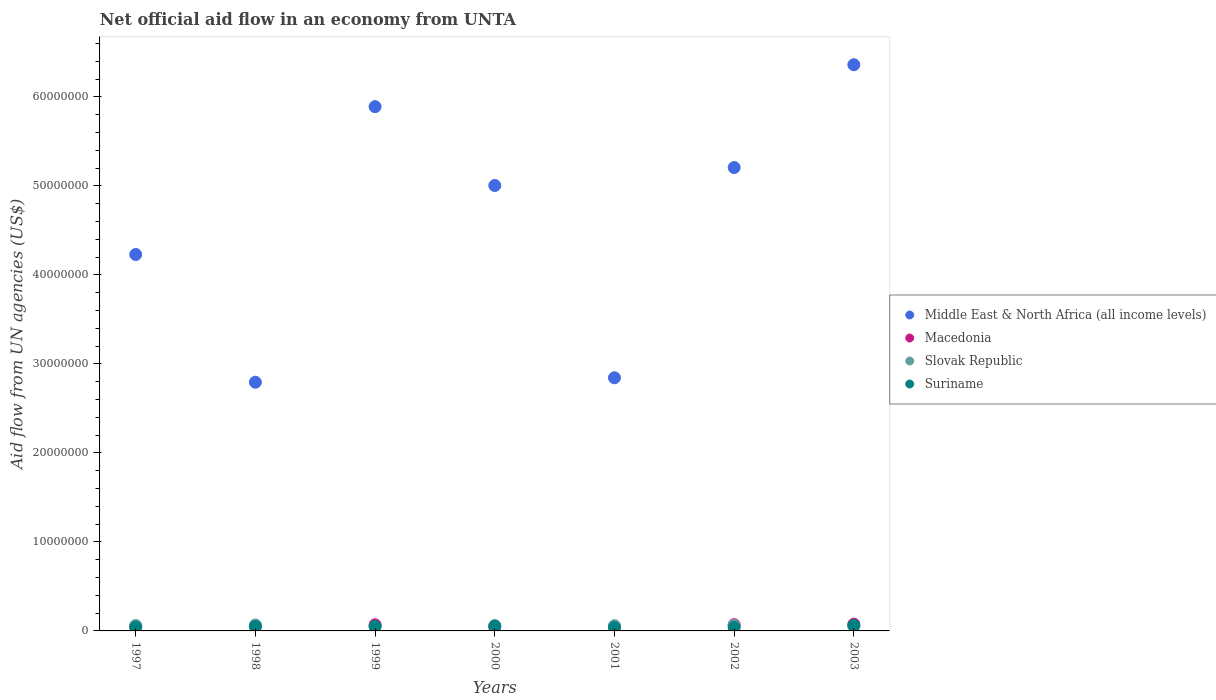How many different coloured dotlines are there?
Your response must be concise. 4. Is the number of dotlines equal to the number of legend labels?
Your answer should be very brief. Yes. What is the net official aid flow in Middle East & North Africa (all income levels) in 2003?
Make the answer very short. 6.36e+07. Across all years, what is the maximum net official aid flow in Slovak Republic?
Make the answer very short. 6.70e+05. Across all years, what is the minimum net official aid flow in Middle East & North Africa (all income levels)?
Provide a short and direct response. 2.79e+07. In which year was the net official aid flow in Macedonia maximum?
Your answer should be compact. 2003. In which year was the net official aid flow in Slovak Republic minimum?
Your response must be concise. 1999. What is the total net official aid flow in Suriname in the graph?
Provide a succinct answer. 3.36e+06. What is the difference between the net official aid flow in Macedonia in 1998 and the net official aid flow in Middle East & North Africa (all income levels) in 2003?
Give a very brief answer. -6.31e+07. What is the average net official aid flow in Macedonia per year?
Your answer should be very brief. 5.83e+05. In the year 2000, what is the difference between the net official aid flow in Suriname and net official aid flow in Macedonia?
Provide a succinct answer. 1.10e+05. In how many years, is the net official aid flow in Slovak Republic greater than 16000000 US$?
Give a very brief answer. 0. What is the ratio of the net official aid flow in Suriname in 2000 to that in 2003?
Your response must be concise. 0.87. Is the difference between the net official aid flow in Suriname in 1998 and 1999 greater than the difference between the net official aid flow in Macedonia in 1998 and 1999?
Your response must be concise. Yes. What is the difference between the highest and the second highest net official aid flow in Suriname?
Your answer should be very brief. 8.00e+04. What is the difference between the highest and the lowest net official aid flow in Middle East & North Africa (all income levels)?
Your response must be concise. 3.57e+07. In how many years, is the net official aid flow in Middle East & North Africa (all income levels) greater than the average net official aid flow in Middle East & North Africa (all income levels) taken over all years?
Keep it short and to the point. 4. Is the sum of the net official aid flow in Macedonia in 1997 and 2000 greater than the maximum net official aid flow in Suriname across all years?
Your answer should be compact. Yes. Is it the case that in every year, the sum of the net official aid flow in Middle East & North Africa (all income levels) and net official aid flow in Suriname  is greater than the sum of net official aid flow in Slovak Republic and net official aid flow in Macedonia?
Ensure brevity in your answer.  Yes. Is the net official aid flow in Macedonia strictly less than the net official aid flow in Slovak Republic over the years?
Keep it short and to the point. No. How many years are there in the graph?
Ensure brevity in your answer.  7. What is the difference between two consecutive major ticks on the Y-axis?
Provide a succinct answer. 1.00e+07. Are the values on the major ticks of Y-axis written in scientific E-notation?
Provide a succinct answer. No. Does the graph contain any zero values?
Your answer should be very brief. No. Where does the legend appear in the graph?
Provide a succinct answer. Center right. How many legend labels are there?
Offer a terse response. 4. How are the legend labels stacked?
Keep it short and to the point. Vertical. What is the title of the graph?
Keep it short and to the point. Net official aid flow in an economy from UNTA. What is the label or title of the X-axis?
Keep it short and to the point. Years. What is the label or title of the Y-axis?
Ensure brevity in your answer.  Aid flow from UN agencies (US$). What is the Aid flow from UN agencies (US$) of Middle East & North Africa (all income levels) in 1997?
Your answer should be compact. 4.23e+07. What is the Aid flow from UN agencies (US$) of Middle East & North Africa (all income levels) in 1998?
Ensure brevity in your answer.  2.79e+07. What is the Aid flow from UN agencies (US$) of Macedonia in 1998?
Offer a very short reply. 5.10e+05. What is the Aid flow from UN agencies (US$) of Slovak Republic in 1998?
Your answer should be very brief. 6.70e+05. What is the Aid flow from UN agencies (US$) in Middle East & North Africa (all income levels) in 1999?
Offer a very short reply. 5.89e+07. What is the Aid flow from UN agencies (US$) in Macedonia in 1999?
Your answer should be compact. 6.90e+05. What is the Aid flow from UN agencies (US$) of Slovak Republic in 1999?
Offer a terse response. 4.70e+05. What is the Aid flow from UN agencies (US$) in Suriname in 1999?
Give a very brief answer. 5.20e+05. What is the Aid flow from UN agencies (US$) in Middle East & North Africa (all income levels) in 2000?
Offer a very short reply. 5.00e+07. What is the Aid flow from UN agencies (US$) in Macedonia in 2000?
Your answer should be compact. 4.30e+05. What is the Aid flow from UN agencies (US$) in Slovak Republic in 2000?
Keep it short and to the point. 6.00e+05. What is the Aid flow from UN agencies (US$) in Suriname in 2000?
Your response must be concise. 5.40e+05. What is the Aid flow from UN agencies (US$) in Middle East & North Africa (all income levels) in 2001?
Give a very brief answer. 2.84e+07. What is the Aid flow from UN agencies (US$) in Macedonia in 2001?
Give a very brief answer. 5.00e+05. What is the Aid flow from UN agencies (US$) in Slovak Republic in 2001?
Provide a short and direct response. 5.90e+05. What is the Aid flow from UN agencies (US$) in Middle East & North Africa (all income levels) in 2002?
Provide a short and direct response. 5.21e+07. What is the Aid flow from UN agencies (US$) of Slovak Republic in 2002?
Your response must be concise. 6.20e+05. What is the Aid flow from UN agencies (US$) in Middle East & North Africa (all income levels) in 2003?
Your answer should be very brief. 6.36e+07. What is the Aid flow from UN agencies (US$) in Macedonia in 2003?
Offer a terse response. 7.60e+05. What is the Aid flow from UN agencies (US$) of Slovak Republic in 2003?
Give a very brief answer. 5.40e+05. What is the Aid flow from UN agencies (US$) in Suriname in 2003?
Ensure brevity in your answer.  6.20e+05. Across all years, what is the maximum Aid flow from UN agencies (US$) in Middle East & North Africa (all income levels)?
Offer a very short reply. 6.36e+07. Across all years, what is the maximum Aid flow from UN agencies (US$) of Macedonia?
Give a very brief answer. 7.60e+05. Across all years, what is the maximum Aid flow from UN agencies (US$) in Slovak Republic?
Ensure brevity in your answer.  6.70e+05. Across all years, what is the maximum Aid flow from UN agencies (US$) in Suriname?
Your answer should be compact. 6.20e+05. Across all years, what is the minimum Aid flow from UN agencies (US$) of Middle East & North Africa (all income levels)?
Ensure brevity in your answer.  2.79e+07. Across all years, what is the minimum Aid flow from UN agencies (US$) of Macedonia?
Keep it short and to the point. 4.30e+05. Across all years, what is the minimum Aid flow from UN agencies (US$) in Slovak Republic?
Your answer should be very brief. 4.70e+05. Across all years, what is the minimum Aid flow from UN agencies (US$) in Suriname?
Offer a terse response. 3.70e+05. What is the total Aid flow from UN agencies (US$) in Middle East & North Africa (all income levels) in the graph?
Offer a terse response. 3.23e+08. What is the total Aid flow from UN agencies (US$) of Macedonia in the graph?
Provide a short and direct response. 4.08e+06. What is the total Aid flow from UN agencies (US$) in Slovak Republic in the graph?
Ensure brevity in your answer.  4.10e+06. What is the total Aid flow from UN agencies (US$) of Suriname in the graph?
Give a very brief answer. 3.36e+06. What is the difference between the Aid flow from UN agencies (US$) of Middle East & North Africa (all income levels) in 1997 and that in 1998?
Provide a succinct answer. 1.44e+07. What is the difference between the Aid flow from UN agencies (US$) of Suriname in 1997 and that in 1998?
Offer a very short reply. -8.00e+04. What is the difference between the Aid flow from UN agencies (US$) in Middle East & North Africa (all income levels) in 1997 and that in 1999?
Provide a succinct answer. -1.66e+07. What is the difference between the Aid flow from UN agencies (US$) in Slovak Republic in 1997 and that in 1999?
Make the answer very short. 1.40e+05. What is the difference between the Aid flow from UN agencies (US$) of Suriname in 1997 and that in 1999?
Offer a very short reply. -1.00e+05. What is the difference between the Aid flow from UN agencies (US$) of Middle East & North Africa (all income levels) in 1997 and that in 2000?
Offer a terse response. -7.75e+06. What is the difference between the Aid flow from UN agencies (US$) in Macedonia in 1997 and that in 2000?
Provide a succinct answer. 6.00e+04. What is the difference between the Aid flow from UN agencies (US$) of Middle East & North Africa (all income levels) in 1997 and that in 2001?
Ensure brevity in your answer.  1.38e+07. What is the difference between the Aid flow from UN agencies (US$) in Macedonia in 1997 and that in 2001?
Make the answer very short. -10000. What is the difference between the Aid flow from UN agencies (US$) in Slovak Republic in 1997 and that in 2001?
Provide a short and direct response. 2.00e+04. What is the difference between the Aid flow from UN agencies (US$) in Suriname in 1997 and that in 2001?
Keep it short and to the point. 5.00e+04. What is the difference between the Aid flow from UN agencies (US$) of Middle East & North Africa (all income levels) in 1997 and that in 2002?
Offer a very short reply. -9.77e+06. What is the difference between the Aid flow from UN agencies (US$) in Slovak Republic in 1997 and that in 2002?
Provide a short and direct response. -10000. What is the difference between the Aid flow from UN agencies (US$) in Middle East & North Africa (all income levels) in 1997 and that in 2003?
Ensure brevity in your answer.  -2.13e+07. What is the difference between the Aid flow from UN agencies (US$) of Macedonia in 1997 and that in 2003?
Provide a short and direct response. -2.70e+05. What is the difference between the Aid flow from UN agencies (US$) in Middle East & North Africa (all income levels) in 1998 and that in 1999?
Give a very brief answer. -3.10e+07. What is the difference between the Aid flow from UN agencies (US$) of Suriname in 1998 and that in 1999?
Keep it short and to the point. -2.00e+04. What is the difference between the Aid flow from UN agencies (US$) in Middle East & North Africa (all income levels) in 1998 and that in 2000?
Keep it short and to the point. -2.21e+07. What is the difference between the Aid flow from UN agencies (US$) in Macedonia in 1998 and that in 2000?
Your answer should be compact. 8.00e+04. What is the difference between the Aid flow from UN agencies (US$) of Slovak Republic in 1998 and that in 2000?
Offer a very short reply. 7.00e+04. What is the difference between the Aid flow from UN agencies (US$) of Middle East & North Africa (all income levels) in 1998 and that in 2001?
Your answer should be compact. -5.00e+05. What is the difference between the Aid flow from UN agencies (US$) in Middle East & North Africa (all income levels) in 1998 and that in 2002?
Ensure brevity in your answer.  -2.41e+07. What is the difference between the Aid flow from UN agencies (US$) in Macedonia in 1998 and that in 2002?
Your response must be concise. -1.90e+05. What is the difference between the Aid flow from UN agencies (US$) of Suriname in 1998 and that in 2002?
Keep it short and to the point. 1.10e+05. What is the difference between the Aid flow from UN agencies (US$) of Middle East & North Africa (all income levels) in 1998 and that in 2003?
Make the answer very short. -3.57e+07. What is the difference between the Aid flow from UN agencies (US$) of Middle East & North Africa (all income levels) in 1999 and that in 2000?
Make the answer very short. 8.86e+06. What is the difference between the Aid flow from UN agencies (US$) in Slovak Republic in 1999 and that in 2000?
Give a very brief answer. -1.30e+05. What is the difference between the Aid flow from UN agencies (US$) of Middle East & North Africa (all income levels) in 1999 and that in 2001?
Give a very brief answer. 3.05e+07. What is the difference between the Aid flow from UN agencies (US$) of Macedonia in 1999 and that in 2001?
Make the answer very short. 1.90e+05. What is the difference between the Aid flow from UN agencies (US$) in Middle East & North Africa (all income levels) in 1999 and that in 2002?
Your response must be concise. 6.84e+06. What is the difference between the Aid flow from UN agencies (US$) in Macedonia in 1999 and that in 2002?
Your answer should be very brief. -10000. What is the difference between the Aid flow from UN agencies (US$) of Slovak Republic in 1999 and that in 2002?
Your answer should be very brief. -1.50e+05. What is the difference between the Aid flow from UN agencies (US$) of Suriname in 1999 and that in 2002?
Offer a very short reply. 1.30e+05. What is the difference between the Aid flow from UN agencies (US$) of Middle East & North Africa (all income levels) in 1999 and that in 2003?
Offer a very short reply. -4.71e+06. What is the difference between the Aid flow from UN agencies (US$) in Slovak Republic in 1999 and that in 2003?
Your answer should be compact. -7.00e+04. What is the difference between the Aid flow from UN agencies (US$) of Middle East & North Africa (all income levels) in 2000 and that in 2001?
Offer a very short reply. 2.16e+07. What is the difference between the Aid flow from UN agencies (US$) of Macedonia in 2000 and that in 2001?
Ensure brevity in your answer.  -7.00e+04. What is the difference between the Aid flow from UN agencies (US$) in Slovak Republic in 2000 and that in 2001?
Make the answer very short. 10000. What is the difference between the Aid flow from UN agencies (US$) of Suriname in 2000 and that in 2001?
Your response must be concise. 1.70e+05. What is the difference between the Aid flow from UN agencies (US$) of Middle East & North Africa (all income levels) in 2000 and that in 2002?
Offer a very short reply. -2.02e+06. What is the difference between the Aid flow from UN agencies (US$) in Macedonia in 2000 and that in 2002?
Make the answer very short. -2.70e+05. What is the difference between the Aid flow from UN agencies (US$) of Slovak Republic in 2000 and that in 2002?
Give a very brief answer. -2.00e+04. What is the difference between the Aid flow from UN agencies (US$) in Suriname in 2000 and that in 2002?
Your answer should be compact. 1.50e+05. What is the difference between the Aid flow from UN agencies (US$) of Middle East & North Africa (all income levels) in 2000 and that in 2003?
Your answer should be compact. -1.36e+07. What is the difference between the Aid flow from UN agencies (US$) of Macedonia in 2000 and that in 2003?
Your answer should be very brief. -3.30e+05. What is the difference between the Aid flow from UN agencies (US$) of Suriname in 2000 and that in 2003?
Provide a succinct answer. -8.00e+04. What is the difference between the Aid flow from UN agencies (US$) of Middle East & North Africa (all income levels) in 2001 and that in 2002?
Keep it short and to the point. -2.36e+07. What is the difference between the Aid flow from UN agencies (US$) in Macedonia in 2001 and that in 2002?
Your answer should be compact. -2.00e+05. What is the difference between the Aid flow from UN agencies (US$) of Slovak Republic in 2001 and that in 2002?
Offer a very short reply. -3.00e+04. What is the difference between the Aid flow from UN agencies (US$) of Suriname in 2001 and that in 2002?
Your answer should be very brief. -2.00e+04. What is the difference between the Aid flow from UN agencies (US$) in Middle East & North Africa (all income levels) in 2001 and that in 2003?
Give a very brief answer. -3.52e+07. What is the difference between the Aid flow from UN agencies (US$) of Middle East & North Africa (all income levels) in 2002 and that in 2003?
Keep it short and to the point. -1.16e+07. What is the difference between the Aid flow from UN agencies (US$) of Macedonia in 2002 and that in 2003?
Your answer should be very brief. -6.00e+04. What is the difference between the Aid flow from UN agencies (US$) of Suriname in 2002 and that in 2003?
Offer a very short reply. -2.30e+05. What is the difference between the Aid flow from UN agencies (US$) of Middle East & North Africa (all income levels) in 1997 and the Aid flow from UN agencies (US$) of Macedonia in 1998?
Give a very brief answer. 4.18e+07. What is the difference between the Aid flow from UN agencies (US$) of Middle East & North Africa (all income levels) in 1997 and the Aid flow from UN agencies (US$) of Slovak Republic in 1998?
Provide a succinct answer. 4.16e+07. What is the difference between the Aid flow from UN agencies (US$) in Middle East & North Africa (all income levels) in 1997 and the Aid flow from UN agencies (US$) in Suriname in 1998?
Provide a succinct answer. 4.18e+07. What is the difference between the Aid flow from UN agencies (US$) in Macedonia in 1997 and the Aid flow from UN agencies (US$) in Suriname in 1998?
Make the answer very short. -10000. What is the difference between the Aid flow from UN agencies (US$) of Slovak Republic in 1997 and the Aid flow from UN agencies (US$) of Suriname in 1998?
Ensure brevity in your answer.  1.10e+05. What is the difference between the Aid flow from UN agencies (US$) in Middle East & North Africa (all income levels) in 1997 and the Aid flow from UN agencies (US$) in Macedonia in 1999?
Ensure brevity in your answer.  4.16e+07. What is the difference between the Aid flow from UN agencies (US$) of Middle East & North Africa (all income levels) in 1997 and the Aid flow from UN agencies (US$) of Slovak Republic in 1999?
Provide a succinct answer. 4.18e+07. What is the difference between the Aid flow from UN agencies (US$) in Middle East & North Africa (all income levels) in 1997 and the Aid flow from UN agencies (US$) in Suriname in 1999?
Your answer should be very brief. 4.18e+07. What is the difference between the Aid flow from UN agencies (US$) of Macedonia in 1997 and the Aid flow from UN agencies (US$) of Suriname in 1999?
Provide a succinct answer. -3.00e+04. What is the difference between the Aid flow from UN agencies (US$) in Slovak Republic in 1997 and the Aid flow from UN agencies (US$) in Suriname in 1999?
Provide a short and direct response. 9.00e+04. What is the difference between the Aid flow from UN agencies (US$) of Middle East & North Africa (all income levels) in 1997 and the Aid flow from UN agencies (US$) of Macedonia in 2000?
Your answer should be very brief. 4.19e+07. What is the difference between the Aid flow from UN agencies (US$) of Middle East & North Africa (all income levels) in 1997 and the Aid flow from UN agencies (US$) of Slovak Republic in 2000?
Your answer should be very brief. 4.17e+07. What is the difference between the Aid flow from UN agencies (US$) of Middle East & North Africa (all income levels) in 1997 and the Aid flow from UN agencies (US$) of Suriname in 2000?
Provide a succinct answer. 4.18e+07. What is the difference between the Aid flow from UN agencies (US$) in Macedonia in 1997 and the Aid flow from UN agencies (US$) in Slovak Republic in 2000?
Your response must be concise. -1.10e+05. What is the difference between the Aid flow from UN agencies (US$) of Macedonia in 1997 and the Aid flow from UN agencies (US$) of Suriname in 2000?
Your response must be concise. -5.00e+04. What is the difference between the Aid flow from UN agencies (US$) of Middle East & North Africa (all income levels) in 1997 and the Aid flow from UN agencies (US$) of Macedonia in 2001?
Your answer should be very brief. 4.18e+07. What is the difference between the Aid flow from UN agencies (US$) in Middle East & North Africa (all income levels) in 1997 and the Aid flow from UN agencies (US$) in Slovak Republic in 2001?
Make the answer very short. 4.17e+07. What is the difference between the Aid flow from UN agencies (US$) of Middle East & North Africa (all income levels) in 1997 and the Aid flow from UN agencies (US$) of Suriname in 2001?
Offer a terse response. 4.19e+07. What is the difference between the Aid flow from UN agencies (US$) in Macedonia in 1997 and the Aid flow from UN agencies (US$) in Slovak Republic in 2001?
Offer a very short reply. -1.00e+05. What is the difference between the Aid flow from UN agencies (US$) of Slovak Republic in 1997 and the Aid flow from UN agencies (US$) of Suriname in 2001?
Ensure brevity in your answer.  2.40e+05. What is the difference between the Aid flow from UN agencies (US$) of Middle East & North Africa (all income levels) in 1997 and the Aid flow from UN agencies (US$) of Macedonia in 2002?
Your response must be concise. 4.16e+07. What is the difference between the Aid flow from UN agencies (US$) in Middle East & North Africa (all income levels) in 1997 and the Aid flow from UN agencies (US$) in Slovak Republic in 2002?
Provide a short and direct response. 4.17e+07. What is the difference between the Aid flow from UN agencies (US$) of Middle East & North Africa (all income levels) in 1997 and the Aid flow from UN agencies (US$) of Suriname in 2002?
Provide a succinct answer. 4.19e+07. What is the difference between the Aid flow from UN agencies (US$) in Slovak Republic in 1997 and the Aid flow from UN agencies (US$) in Suriname in 2002?
Ensure brevity in your answer.  2.20e+05. What is the difference between the Aid flow from UN agencies (US$) in Middle East & North Africa (all income levels) in 1997 and the Aid flow from UN agencies (US$) in Macedonia in 2003?
Your answer should be very brief. 4.15e+07. What is the difference between the Aid flow from UN agencies (US$) of Middle East & North Africa (all income levels) in 1997 and the Aid flow from UN agencies (US$) of Slovak Republic in 2003?
Your answer should be very brief. 4.18e+07. What is the difference between the Aid flow from UN agencies (US$) in Middle East & North Africa (all income levels) in 1997 and the Aid flow from UN agencies (US$) in Suriname in 2003?
Make the answer very short. 4.17e+07. What is the difference between the Aid flow from UN agencies (US$) of Macedonia in 1997 and the Aid flow from UN agencies (US$) of Slovak Republic in 2003?
Your response must be concise. -5.00e+04. What is the difference between the Aid flow from UN agencies (US$) in Macedonia in 1997 and the Aid flow from UN agencies (US$) in Suriname in 2003?
Offer a terse response. -1.30e+05. What is the difference between the Aid flow from UN agencies (US$) of Middle East & North Africa (all income levels) in 1998 and the Aid flow from UN agencies (US$) of Macedonia in 1999?
Offer a terse response. 2.72e+07. What is the difference between the Aid flow from UN agencies (US$) in Middle East & North Africa (all income levels) in 1998 and the Aid flow from UN agencies (US$) in Slovak Republic in 1999?
Keep it short and to the point. 2.75e+07. What is the difference between the Aid flow from UN agencies (US$) of Middle East & North Africa (all income levels) in 1998 and the Aid flow from UN agencies (US$) of Suriname in 1999?
Provide a succinct answer. 2.74e+07. What is the difference between the Aid flow from UN agencies (US$) in Slovak Republic in 1998 and the Aid flow from UN agencies (US$) in Suriname in 1999?
Give a very brief answer. 1.50e+05. What is the difference between the Aid flow from UN agencies (US$) in Middle East & North Africa (all income levels) in 1998 and the Aid flow from UN agencies (US$) in Macedonia in 2000?
Offer a very short reply. 2.75e+07. What is the difference between the Aid flow from UN agencies (US$) in Middle East & North Africa (all income levels) in 1998 and the Aid flow from UN agencies (US$) in Slovak Republic in 2000?
Offer a terse response. 2.73e+07. What is the difference between the Aid flow from UN agencies (US$) in Middle East & North Africa (all income levels) in 1998 and the Aid flow from UN agencies (US$) in Suriname in 2000?
Your answer should be very brief. 2.74e+07. What is the difference between the Aid flow from UN agencies (US$) of Macedonia in 1998 and the Aid flow from UN agencies (US$) of Slovak Republic in 2000?
Give a very brief answer. -9.00e+04. What is the difference between the Aid flow from UN agencies (US$) in Macedonia in 1998 and the Aid flow from UN agencies (US$) in Suriname in 2000?
Provide a succinct answer. -3.00e+04. What is the difference between the Aid flow from UN agencies (US$) of Slovak Republic in 1998 and the Aid flow from UN agencies (US$) of Suriname in 2000?
Provide a short and direct response. 1.30e+05. What is the difference between the Aid flow from UN agencies (US$) in Middle East & North Africa (all income levels) in 1998 and the Aid flow from UN agencies (US$) in Macedonia in 2001?
Your response must be concise. 2.74e+07. What is the difference between the Aid flow from UN agencies (US$) in Middle East & North Africa (all income levels) in 1998 and the Aid flow from UN agencies (US$) in Slovak Republic in 2001?
Make the answer very short. 2.74e+07. What is the difference between the Aid flow from UN agencies (US$) of Middle East & North Africa (all income levels) in 1998 and the Aid flow from UN agencies (US$) of Suriname in 2001?
Your response must be concise. 2.76e+07. What is the difference between the Aid flow from UN agencies (US$) of Macedonia in 1998 and the Aid flow from UN agencies (US$) of Slovak Republic in 2001?
Ensure brevity in your answer.  -8.00e+04. What is the difference between the Aid flow from UN agencies (US$) in Slovak Republic in 1998 and the Aid flow from UN agencies (US$) in Suriname in 2001?
Provide a succinct answer. 3.00e+05. What is the difference between the Aid flow from UN agencies (US$) in Middle East & North Africa (all income levels) in 1998 and the Aid flow from UN agencies (US$) in Macedonia in 2002?
Provide a short and direct response. 2.72e+07. What is the difference between the Aid flow from UN agencies (US$) in Middle East & North Africa (all income levels) in 1998 and the Aid flow from UN agencies (US$) in Slovak Republic in 2002?
Make the answer very short. 2.73e+07. What is the difference between the Aid flow from UN agencies (US$) in Middle East & North Africa (all income levels) in 1998 and the Aid flow from UN agencies (US$) in Suriname in 2002?
Provide a succinct answer. 2.76e+07. What is the difference between the Aid flow from UN agencies (US$) in Slovak Republic in 1998 and the Aid flow from UN agencies (US$) in Suriname in 2002?
Make the answer very short. 2.80e+05. What is the difference between the Aid flow from UN agencies (US$) of Middle East & North Africa (all income levels) in 1998 and the Aid flow from UN agencies (US$) of Macedonia in 2003?
Provide a short and direct response. 2.72e+07. What is the difference between the Aid flow from UN agencies (US$) of Middle East & North Africa (all income levels) in 1998 and the Aid flow from UN agencies (US$) of Slovak Republic in 2003?
Your answer should be very brief. 2.74e+07. What is the difference between the Aid flow from UN agencies (US$) in Middle East & North Africa (all income levels) in 1998 and the Aid flow from UN agencies (US$) in Suriname in 2003?
Make the answer very short. 2.73e+07. What is the difference between the Aid flow from UN agencies (US$) in Macedonia in 1998 and the Aid flow from UN agencies (US$) in Slovak Republic in 2003?
Your answer should be very brief. -3.00e+04. What is the difference between the Aid flow from UN agencies (US$) in Macedonia in 1998 and the Aid flow from UN agencies (US$) in Suriname in 2003?
Your answer should be very brief. -1.10e+05. What is the difference between the Aid flow from UN agencies (US$) in Middle East & North Africa (all income levels) in 1999 and the Aid flow from UN agencies (US$) in Macedonia in 2000?
Give a very brief answer. 5.85e+07. What is the difference between the Aid flow from UN agencies (US$) of Middle East & North Africa (all income levels) in 1999 and the Aid flow from UN agencies (US$) of Slovak Republic in 2000?
Your answer should be compact. 5.83e+07. What is the difference between the Aid flow from UN agencies (US$) in Middle East & North Africa (all income levels) in 1999 and the Aid flow from UN agencies (US$) in Suriname in 2000?
Your answer should be very brief. 5.84e+07. What is the difference between the Aid flow from UN agencies (US$) in Macedonia in 1999 and the Aid flow from UN agencies (US$) in Slovak Republic in 2000?
Your response must be concise. 9.00e+04. What is the difference between the Aid flow from UN agencies (US$) in Slovak Republic in 1999 and the Aid flow from UN agencies (US$) in Suriname in 2000?
Give a very brief answer. -7.00e+04. What is the difference between the Aid flow from UN agencies (US$) in Middle East & North Africa (all income levels) in 1999 and the Aid flow from UN agencies (US$) in Macedonia in 2001?
Keep it short and to the point. 5.84e+07. What is the difference between the Aid flow from UN agencies (US$) of Middle East & North Africa (all income levels) in 1999 and the Aid flow from UN agencies (US$) of Slovak Republic in 2001?
Ensure brevity in your answer.  5.83e+07. What is the difference between the Aid flow from UN agencies (US$) in Middle East & North Africa (all income levels) in 1999 and the Aid flow from UN agencies (US$) in Suriname in 2001?
Offer a very short reply. 5.85e+07. What is the difference between the Aid flow from UN agencies (US$) of Macedonia in 1999 and the Aid flow from UN agencies (US$) of Suriname in 2001?
Provide a succinct answer. 3.20e+05. What is the difference between the Aid flow from UN agencies (US$) in Middle East & North Africa (all income levels) in 1999 and the Aid flow from UN agencies (US$) in Macedonia in 2002?
Make the answer very short. 5.82e+07. What is the difference between the Aid flow from UN agencies (US$) of Middle East & North Africa (all income levels) in 1999 and the Aid flow from UN agencies (US$) of Slovak Republic in 2002?
Provide a short and direct response. 5.83e+07. What is the difference between the Aid flow from UN agencies (US$) of Middle East & North Africa (all income levels) in 1999 and the Aid flow from UN agencies (US$) of Suriname in 2002?
Offer a very short reply. 5.85e+07. What is the difference between the Aid flow from UN agencies (US$) in Macedonia in 1999 and the Aid flow from UN agencies (US$) in Slovak Republic in 2002?
Make the answer very short. 7.00e+04. What is the difference between the Aid flow from UN agencies (US$) of Macedonia in 1999 and the Aid flow from UN agencies (US$) of Suriname in 2002?
Give a very brief answer. 3.00e+05. What is the difference between the Aid flow from UN agencies (US$) of Middle East & North Africa (all income levels) in 1999 and the Aid flow from UN agencies (US$) of Macedonia in 2003?
Give a very brief answer. 5.81e+07. What is the difference between the Aid flow from UN agencies (US$) of Middle East & North Africa (all income levels) in 1999 and the Aid flow from UN agencies (US$) of Slovak Republic in 2003?
Offer a terse response. 5.84e+07. What is the difference between the Aid flow from UN agencies (US$) of Middle East & North Africa (all income levels) in 1999 and the Aid flow from UN agencies (US$) of Suriname in 2003?
Make the answer very short. 5.83e+07. What is the difference between the Aid flow from UN agencies (US$) in Macedonia in 1999 and the Aid flow from UN agencies (US$) in Suriname in 2003?
Ensure brevity in your answer.  7.00e+04. What is the difference between the Aid flow from UN agencies (US$) in Slovak Republic in 1999 and the Aid flow from UN agencies (US$) in Suriname in 2003?
Keep it short and to the point. -1.50e+05. What is the difference between the Aid flow from UN agencies (US$) in Middle East & North Africa (all income levels) in 2000 and the Aid flow from UN agencies (US$) in Macedonia in 2001?
Provide a succinct answer. 4.95e+07. What is the difference between the Aid flow from UN agencies (US$) of Middle East & North Africa (all income levels) in 2000 and the Aid flow from UN agencies (US$) of Slovak Republic in 2001?
Offer a terse response. 4.94e+07. What is the difference between the Aid flow from UN agencies (US$) in Middle East & North Africa (all income levels) in 2000 and the Aid flow from UN agencies (US$) in Suriname in 2001?
Keep it short and to the point. 4.97e+07. What is the difference between the Aid flow from UN agencies (US$) of Macedonia in 2000 and the Aid flow from UN agencies (US$) of Suriname in 2001?
Provide a short and direct response. 6.00e+04. What is the difference between the Aid flow from UN agencies (US$) of Middle East & North Africa (all income levels) in 2000 and the Aid flow from UN agencies (US$) of Macedonia in 2002?
Your answer should be very brief. 4.93e+07. What is the difference between the Aid flow from UN agencies (US$) in Middle East & North Africa (all income levels) in 2000 and the Aid flow from UN agencies (US$) in Slovak Republic in 2002?
Offer a very short reply. 4.94e+07. What is the difference between the Aid flow from UN agencies (US$) in Middle East & North Africa (all income levels) in 2000 and the Aid flow from UN agencies (US$) in Suriname in 2002?
Your answer should be compact. 4.96e+07. What is the difference between the Aid flow from UN agencies (US$) of Macedonia in 2000 and the Aid flow from UN agencies (US$) of Suriname in 2002?
Ensure brevity in your answer.  4.00e+04. What is the difference between the Aid flow from UN agencies (US$) of Middle East & North Africa (all income levels) in 2000 and the Aid flow from UN agencies (US$) of Macedonia in 2003?
Your response must be concise. 4.93e+07. What is the difference between the Aid flow from UN agencies (US$) of Middle East & North Africa (all income levels) in 2000 and the Aid flow from UN agencies (US$) of Slovak Republic in 2003?
Give a very brief answer. 4.95e+07. What is the difference between the Aid flow from UN agencies (US$) of Middle East & North Africa (all income levels) in 2000 and the Aid flow from UN agencies (US$) of Suriname in 2003?
Give a very brief answer. 4.94e+07. What is the difference between the Aid flow from UN agencies (US$) in Macedonia in 2000 and the Aid flow from UN agencies (US$) in Slovak Republic in 2003?
Keep it short and to the point. -1.10e+05. What is the difference between the Aid flow from UN agencies (US$) in Middle East & North Africa (all income levels) in 2001 and the Aid flow from UN agencies (US$) in Macedonia in 2002?
Provide a succinct answer. 2.77e+07. What is the difference between the Aid flow from UN agencies (US$) of Middle East & North Africa (all income levels) in 2001 and the Aid flow from UN agencies (US$) of Slovak Republic in 2002?
Offer a terse response. 2.78e+07. What is the difference between the Aid flow from UN agencies (US$) of Middle East & North Africa (all income levels) in 2001 and the Aid flow from UN agencies (US$) of Suriname in 2002?
Your answer should be very brief. 2.80e+07. What is the difference between the Aid flow from UN agencies (US$) of Macedonia in 2001 and the Aid flow from UN agencies (US$) of Slovak Republic in 2002?
Ensure brevity in your answer.  -1.20e+05. What is the difference between the Aid flow from UN agencies (US$) in Middle East & North Africa (all income levels) in 2001 and the Aid flow from UN agencies (US$) in Macedonia in 2003?
Ensure brevity in your answer.  2.77e+07. What is the difference between the Aid flow from UN agencies (US$) of Middle East & North Africa (all income levels) in 2001 and the Aid flow from UN agencies (US$) of Slovak Republic in 2003?
Ensure brevity in your answer.  2.79e+07. What is the difference between the Aid flow from UN agencies (US$) in Middle East & North Africa (all income levels) in 2001 and the Aid flow from UN agencies (US$) in Suriname in 2003?
Your answer should be very brief. 2.78e+07. What is the difference between the Aid flow from UN agencies (US$) of Macedonia in 2001 and the Aid flow from UN agencies (US$) of Suriname in 2003?
Offer a very short reply. -1.20e+05. What is the difference between the Aid flow from UN agencies (US$) of Middle East & North Africa (all income levels) in 2002 and the Aid flow from UN agencies (US$) of Macedonia in 2003?
Provide a short and direct response. 5.13e+07. What is the difference between the Aid flow from UN agencies (US$) of Middle East & North Africa (all income levels) in 2002 and the Aid flow from UN agencies (US$) of Slovak Republic in 2003?
Offer a terse response. 5.15e+07. What is the difference between the Aid flow from UN agencies (US$) of Middle East & North Africa (all income levels) in 2002 and the Aid flow from UN agencies (US$) of Suriname in 2003?
Offer a terse response. 5.14e+07. What is the difference between the Aid flow from UN agencies (US$) of Macedonia in 2002 and the Aid flow from UN agencies (US$) of Slovak Republic in 2003?
Your answer should be very brief. 1.60e+05. What is the difference between the Aid flow from UN agencies (US$) in Macedonia in 2002 and the Aid flow from UN agencies (US$) in Suriname in 2003?
Offer a very short reply. 8.00e+04. What is the average Aid flow from UN agencies (US$) in Middle East & North Africa (all income levels) per year?
Give a very brief answer. 4.62e+07. What is the average Aid flow from UN agencies (US$) in Macedonia per year?
Your response must be concise. 5.83e+05. What is the average Aid flow from UN agencies (US$) in Slovak Republic per year?
Your response must be concise. 5.86e+05. In the year 1997, what is the difference between the Aid flow from UN agencies (US$) in Middle East & North Africa (all income levels) and Aid flow from UN agencies (US$) in Macedonia?
Give a very brief answer. 4.18e+07. In the year 1997, what is the difference between the Aid flow from UN agencies (US$) in Middle East & North Africa (all income levels) and Aid flow from UN agencies (US$) in Slovak Republic?
Provide a succinct answer. 4.17e+07. In the year 1997, what is the difference between the Aid flow from UN agencies (US$) of Middle East & North Africa (all income levels) and Aid flow from UN agencies (US$) of Suriname?
Offer a very short reply. 4.19e+07. In the year 1997, what is the difference between the Aid flow from UN agencies (US$) of Macedonia and Aid flow from UN agencies (US$) of Slovak Republic?
Your answer should be very brief. -1.20e+05. In the year 1997, what is the difference between the Aid flow from UN agencies (US$) in Slovak Republic and Aid flow from UN agencies (US$) in Suriname?
Your answer should be compact. 1.90e+05. In the year 1998, what is the difference between the Aid flow from UN agencies (US$) in Middle East & North Africa (all income levels) and Aid flow from UN agencies (US$) in Macedonia?
Provide a succinct answer. 2.74e+07. In the year 1998, what is the difference between the Aid flow from UN agencies (US$) of Middle East & North Africa (all income levels) and Aid flow from UN agencies (US$) of Slovak Republic?
Keep it short and to the point. 2.73e+07. In the year 1998, what is the difference between the Aid flow from UN agencies (US$) in Middle East & North Africa (all income levels) and Aid flow from UN agencies (US$) in Suriname?
Give a very brief answer. 2.74e+07. In the year 1998, what is the difference between the Aid flow from UN agencies (US$) of Macedonia and Aid flow from UN agencies (US$) of Slovak Republic?
Keep it short and to the point. -1.60e+05. In the year 1999, what is the difference between the Aid flow from UN agencies (US$) of Middle East & North Africa (all income levels) and Aid flow from UN agencies (US$) of Macedonia?
Your answer should be compact. 5.82e+07. In the year 1999, what is the difference between the Aid flow from UN agencies (US$) in Middle East & North Africa (all income levels) and Aid flow from UN agencies (US$) in Slovak Republic?
Give a very brief answer. 5.84e+07. In the year 1999, what is the difference between the Aid flow from UN agencies (US$) in Middle East & North Africa (all income levels) and Aid flow from UN agencies (US$) in Suriname?
Ensure brevity in your answer.  5.84e+07. In the year 1999, what is the difference between the Aid flow from UN agencies (US$) in Macedonia and Aid flow from UN agencies (US$) in Suriname?
Your response must be concise. 1.70e+05. In the year 1999, what is the difference between the Aid flow from UN agencies (US$) in Slovak Republic and Aid flow from UN agencies (US$) in Suriname?
Provide a short and direct response. -5.00e+04. In the year 2000, what is the difference between the Aid flow from UN agencies (US$) of Middle East & North Africa (all income levels) and Aid flow from UN agencies (US$) of Macedonia?
Provide a short and direct response. 4.96e+07. In the year 2000, what is the difference between the Aid flow from UN agencies (US$) in Middle East & North Africa (all income levels) and Aid flow from UN agencies (US$) in Slovak Republic?
Your answer should be very brief. 4.94e+07. In the year 2000, what is the difference between the Aid flow from UN agencies (US$) in Middle East & North Africa (all income levels) and Aid flow from UN agencies (US$) in Suriname?
Provide a succinct answer. 4.95e+07. In the year 2000, what is the difference between the Aid flow from UN agencies (US$) in Macedonia and Aid flow from UN agencies (US$) in Slovak Republic?
Make the answer very short. -1.70e+05. In the year 2001, what is the difference between the Aid flow from UN agencies (US$) in Middle East & North Africa (all income levels) and Aid flow from UN agencies (US$) in Macedonia?
Keep it short and to the point. 2.79e+07. In the year 2001, what is the difference between the Aid flow from UN agencies (US$) of Middle East & North Africa (all income levels) and Aid flow from UN agencies (US$) of Slovak Republic?
Your answer should be compact. 2.78e+07. In the year 2001, what is the difference between the Aid flow from UN agencies (US$) of Middle East & North Africa (all income levels) and Aid flow from UN agencies (US$) of Suriname?
Give a very brief answer. 2.81e+07. In the year 2001, what is the difference between the Aid flow from UN agencies (US$) in Macedonia and Aid flow from UN agencies (US$) in Suriname?
Offer a terse response. 1.30e+05. In the year 2001, what is the difference between the Aid flow from UN agencies (US$) in Slovak Republic and Aid flow from UN agencies (US$) in Suriname?
Give a very brief answer. 2.20e+05. In the year 2002, what is the difference between the Aid flow from UN agencies (US$) in Middle East & North Africa (all income levels) and Aid flow from UN agencies (US$) in Macedonia?
Your answer should be very brief. 5.14e+07. In the year 2002, what is the difference between the Aid flow from UN agencies (US$) in Middle East & North Africa (all income levels) and Aid flow from UN agencies (US$) in Slovak Republic?
Provide a succinct answer. 5.14e+07. In the year 2002, what is the difference between the Aid flow from UN agencies (US$) in Middle East & North Africa (all income levels) and Aid flow from UN agencies (US$) in Suriname?
Provide a short and direct response. 5.17e+07. In the year 2003, what is the difference between the Aid flow from UN agencies (US$) of Middle East & North Africa (all income levels) and Aid flow from UN agencies (US$) of Macedonia?
Provide a succinct answer. 6.28e+07. In the year 2003, what is the difference between the Aid flow from UN agencies (US$) of Middle East & North Africa (all income levels) and Aid flow from UN agencies (US$) of Slovak Republic?
Offer a terse response. 6.31e+07. In the year 2003, what is the difference between the Aid flow from UN agencies (US$) of Middle East & North Africa (all income levels) and Aid flow from UN agencies (US$) of Suriname?
Your response must be concise. 6.30e+07. In the year 2003, what is the difference between the Aid flow from UN agencies (US$) in Macedonia and Aid flow from UN agencies (US$) in Suriname?
Make the answer very short. 1.40e+05. In the year 2003, what is the difference between the Aid flow from UN agencies (US$) in Slovak Republic and Aid flow from UN agencies (US$) in Suriname?
Provide a succinct answer. -8.00e+04. What is the ratio of the Aid flow from UN agencies (US$) in Middle East & North Africa (all income levels) in 1997 to that in 1998?
Your response must be concise. 1.51. What is the ratio of the Aid flow from UN agencies (US$) in Macedonia in 1997 to that in 1998?
Provide a short and direct response. 0.96. What is the ratio of the Aid flow from UN agencies (US$) in Slovak Republic in 1997 to that in 1998?
Keep it short and to the point. 0.91. What is the ratio of the Aid flow from UN agencies (US$) in Suriname in 1997 to that in 1998?
Ensure brevity in your answer.  0.84. What is the ratio of the Aid flow from UN agencies (US$) in Middle East & North Africa (all income levels) in 1997 to that in 1999?
Offer a terse response. 0.72. What is the ratio of the Aid flow from UN agencies (US$) in Macedonia in 1997 to that in 1999?
Provide a short and direct response. 0.71. What is the ratio of the Aid flow from UN agencies (US$) of Slovak Republic in 1997 to that in 1999?
Make the answer very short. 1.3. What is the ratio of the Aid flow from UN agencies (US$) in Suriname in 1997 to that in 1999?
Offer a terse response. 0.81. What is the ratio of the Aid flow from UN agencies (US$) of Middle East & North Africa (all income levels) in 1997 to that in 2000?
Offer a terse response. 0.85. What is the ratio of the Aid flow from UN agencies (US$) of Macedonia in 1997 to that in 2000?
Ensure brevity in your answer.  1.14. What is the ratio of the Aid flow from UN agencies (US$) in Slovak Republic in 1997 to that in 2000?
Your response must be concise. 1.02. What is the ratio of the Aid flow from UN agencies (US$) in Suriname in 1997 to that in 2000?
Provide a short and direct response. 0.78. What is the ratio of the Aid flow from UN agencies (US$) of Middle East & North Africa (all income levels) in 1997 to that in 2001?
Provide a succinct answer. 1.49. What is the ratio of the Aid flow from UN agencies (US$) in Macedonia in 1997 to that in 2001?
Provide a short and direct response. 0.98. What is the ratio of the Aid flow from UN agencies (US$) in Slovak Republic in 1997 to that in 2001?
Give a very brief answer. 1.03. What is the ratio of the Aid flow from UN agencies (US$) of Suriname in 1997 to that in 2001?
Ensure brevity in your answer.  1.14. What is the ratio of the Aid flow from UN agencies (US$) in Middle East & North Africa (all income levels) in 1997 to that in 2002?
Ensure brevity in your answer.  0.81. What is the ratio of the Aid flow from UN agencies (US$) in Macedonia in 1997 to that in 2002?
Give a very brief answer. 0.7. What is the ratio of the Aid flow from UN agencies (US$) in Slovak Republic in 1997 to that in 2002?
Provide a succinct answer. 0.98. What is the ratio of the Aid flow from UN agencies (US$) of Middle East & North Africa (all income levels) in 1997 to that in 2003?
Provide a short and direct response. 0.66. What is the ratio of the Aid flow from UN agencies (US$) of Macedonia in 1997 to that in 2003?
Provide a succinct answer. 0.64. What is the ratio of the Aid flow from UN agencies (US$) in Slovak Republic in 1997 to that in 2003?
Keep it short and to the point. 1.13. What is the ratio of the Aid flow from UN agencies (US$) of Suriname in 1997 to that in 2003?
Provide a succinct answer. 0.68. What is the ratio of the Aid flow from UN agencies (US$) of Middle East & North Africa (all income levels) in 1998 to that in 1999?
Your answer should be compact. 0.47. What is the ratio of the Aid flow from UN agencies (US$) of Macedonia in 1998 to that in 1999?
Offer a very short reply. 0.74. What is the ratio of the Aid flow from UN agencies (US$) of Slovak Republic in 1998 to that in 1999?
Your response must be concise. 1.43. What is the ratio of the Aid flow from UN agencies (US$) in Suriname in 1998 to that in 1999?
Ensure brevity in your answer.  0.96. What is the ratio of the Aid flow from UN agencies (US$) of Middle East & North Africa (all income levels) in 1998 to that in 2000?
Your response must be concise. 0.56. What is the ratio of the Aid flow from UN agencies (US$) in Macedonia in 1998 to that in 2000?
Offer a very short reply. 1.19. What is the ratio of the Aid flow from UN agencies (US$) in Slovak Republic in 1998 to that in 2000?
Keep it short and to the point. 1.12. What is the ratio of the Aid flow from UN agencies (US$) of Suriname in 1998 to that in 2000?
Keep it short and to the point. 0.93. What is the ratio of the Aid flow from UN agencies (US$) in Middle East & North Africa (all income levels) in 1998 to that in 2001?
Provide a succinct answer. 0.98. What is the ratio of the Aid flow from UN agencies (US$) in Macedonia in 1998 to that in 2001?
Your response must be concise. 1.02. What is the ratio of the Aid flow from UN agencies (US$) in Slovak Republic in 1998 to that in 2001?
Give a very brief answer. 1.14. What is the ratio of the Aid flow from UN agencies (US$) in Suriname in 1998 to that in 2001?
Make the answer very short. 1.35. What is the ratio of the Aid flow from UN agencies (US$) in Middle East & North Africa (all income levels) in 1998 to that in 2002?
Offer a very short reply. 0.54. What is the ratio of the Aid flow from UN agencies (US$) of Macedonia in 1998 to that in 2002?
Provide a succinct answer. 0.73. What is the ratio of the Aid flow from UN agencies (US$) of Slovak Republic in 1998 to that in 2002?
Your answer should be very brief. 1.08. What is the ratio of the Aid flow from UN agencies (US$) in Suriname in 1998 to that in 2002?
Offer a very short reply. 1.28. What is the ratio of the Aid flow from UN agencies (US$) in Middle East & North Africa (all income levels) in 1998 to that in 2003?
Your response must be concise. 0.44. What is the ratio of the Aid flow from UN agencies (US$) in Macedonia in 1998 to that in 2003?
Ensure brevity in your answer.  0.67. What is the ratio of the Aid flow from UN agencies (US$) in Slovak Republic in 1998 to that in 2003?
Offer a terse response. 1.24. What is the ratio of the Aid flow from UN agencies (US$) of Suriname in 1998 to that in 2003?
Keep it short and to the point. 0.81. What is the ratio of the Aid flow from UN agencies (US$) in Middle East & North Africa (all income levels) in 1999 to that in 2000?
Give a very brief answer. 1.18. What is the ratio of the Aid flow from UN agencies (US$) in Macedonia in 1999 to that in 2000?
Your answer should be very brief. 1.6. What is the ratio of the Aid flow from UN agencies (US$) in Slovak Republic in 1999 to that in 2000?
Your response must be concise. 0.78. What is the ratio of the Aid flow from UN agencies (US$) of Suriname in 1999 to that in 2000?
Provide a succinct answer. 0.96. What is the ratio of the Aid flow from UN agencies (US$) in Middle East & North Africa (all income levels) in 1999 to that in 2001?
Give a very brief answer. 2.07. What is the ratio of the Aid flow from UN agencies (US$) in Macedonia in 1999 to that in 2001?
Give a very brief answer. 1.38. What is the ratio of the Aid flow from UN agencies (US$) in Slovak Republic in 1999 to that in 2001?
Provide a succinct answer. 0.8. What is the ratio of the Aid flow from UN agencies (US$) of Suriname in 1999 to that in 2001?
Give a very brief answer. 1.41. What is the ratio of the Aid flow from UN agencies (US$) in Middle East & North Africa (all income levels) in 1999 to that in 2002?
Your answer should be compact. 1.13. What is the ratio of the Aid flow from UN agencies (US$) in Macedonia in 1999 to that in 2002?
Give a very brief answer. 0.99. What is the ratio of the Aid flow from UN agencies (US$) in Slovak Republic in 1999 to that in 2002?
Your response must be concise. 0.76. What is the ratio of the Aid flow from UN agencies (US$) in Suriname in 1999 to that in 2002?
Your answer should be compact. 1.33. What is the ratio of the Aid flow from UN agencies (US$) of Middle East & North Africa (all income levels) in 1999 to that in 2003?
Your response must be concise. 0.93. What is the ratio of the Aid flow from UN agencies (US$) in Macedonia in 1999 to that in 2003?
Your response must be concise. 0.91. What is the ratio of the Aid flow from UN agencies (US$) in Slovak Republic in 1999 to that in 2003?
Keep it short and to the point. 0.87. What is the ratio of the Aid flow from UN agencies (US$) in Suriname in 1999 to that in 2003?
Offer a terse response. 0.84. What is the ratio of the Aid flow from UN agencies (US$) in Middle East & North Africa (all income levels) in 2000 to that in 2001?
Your answer should be compact. 1.76. What is the ratio of the Aid flow from UN agencies (US$) of Macedonia in 2000 to that in 2001?
Give a very brief answer. 0.86. What is the ratio of the Aid flow from UN agencies (US$) of Slovak Republic in 2000 to that in 2001?
Your answer should be compact. 1.02. What is the ratio of the Aid flow from UN agencies (US$) in Suriname in 2000 to that in 2001?
Keep it short and to the point. 1.46. What is the ratio of the Aid flow from UN agencies (US$) in Middle East & North Africa (all income levels) in 2000 to that in 2002?
Provide a succinct answer. 0.96. What is the ratio of the Aid flow from UN agencies (US$) of Macedonia in 2000 to that in 2002?
Provide a short and direct response. 0.61. What is the ratio of the Aid flow from UN agencies (US$) in Suriname in 2000 to that in 2002?
Make the answer very short. 1.38. What is the ratio of the Aid flow from UN agencies (US$) in Middle East & North Africa (all income levels) in 2000 to that in 2003?
Ensure brevity in your answer.  0.79. What is the ratio of the Aid flow from UN agencies (US$) in Macedonia in 2000 to that in 2003?
Give a very brief answer. 0.57. What is the ratio of the Aid flow from UN agencies (US$) of Slovak Republic in 2000 to that in 2003?
Your answer should be very brief. 1.11. What is the ratio of the Aid flow from UN agencies (US$) of Suriname in 2000 to that in 2003?
Provide a short and direct response. 0.87. What is the ratio of the Aid flow from UN agencies (US$) of Middle East & North Africa (all income levels) in 2001 to that in 2002?
Your response must be concise. 0.55. What is the ratio of the Aid flow from UN agencies (US$) in Macedonia in 2001 to that in 2002?
Provide a short and direct response. 0.71. What is the ratio of the Aid flow from UN agencies (US$) of Slovak Republic in 2001 to that in 2002?
Offer a terse response. 0.95. What is the ratio of the Aid flow from UN agencies (US$) of Suriname in 2001 to that in 2002?
Your response must be concise. 0.95. What is the ratio of the Aid flow from UN agencies (US$) in Middle East & North Africa (all income levels) in 2001 to that in 2003?
Offer a terse response. 0.45. What is the ratio of the Aid flow from UN agencies (US$) in Macedonia in 2001 to that in 2003?
Provide a succinct answer. 0.66. What is the ratio of the Aid flow from UN agencies (US$) of Slovak Republic in 2001 to that in 2003?
Offer a very short reply. 1.09. What is the ratio of the Aid flow from UN agencies (US$) of Suriname in 2001 to that in 2003?
Make the answer very short. 0.6. What is the ratio of the Aid flow from UN agencies (US$) in Middle East & North Africa (all income levels) in 2002 to that in 2003?
Give a very brief answer. 0.82. What is the ratio of the Aid flow from UN agencies (US$) of Macedonia in 2002 to that in 2003?
Your response must be concise. 0.92. What is the ratio of the Aid flow from UN agencies (US$) of Slovak Republic in 2002 to that in 2003?
Your response must be concise. 1.15. What is the ratio of the Aid flow from UN agencies (US$) in Suriname in 2002 to that in 2003?
Your response must be concise. 0.63. What is the difference between the highest and the second highest Aid flow from UN agencies (US$) in Middle East & North Africa (all income levels)?
Offer a terse response. 4.71e+06. What is the difference between the highest and the second highest Aid flow from UN agencies (US$) of Macedonia?
Your response must be concise. 6.00e+04. What is the difference between the highest and the second highest Aid flow from UN agencies (US$) in Slovak Republic?
Give a very brief answer. 5.00e+04. What is the difference between the highest and the lowest Aid flow from UN agencies (US$) in Middle East & North Africa (all income levels)?
Give a very brief answer. 3.57e+07. What is the difference between the highest and the lowest Aid flow from UN agencies (US$) of Slovak Republic?
Offer a terse response. 2.00e+05. What is the difference between the highest and the lowest Aid flow from UN agencies (US$) in Suriname?
Ensure brevity in your answer.  2.50e+05. 